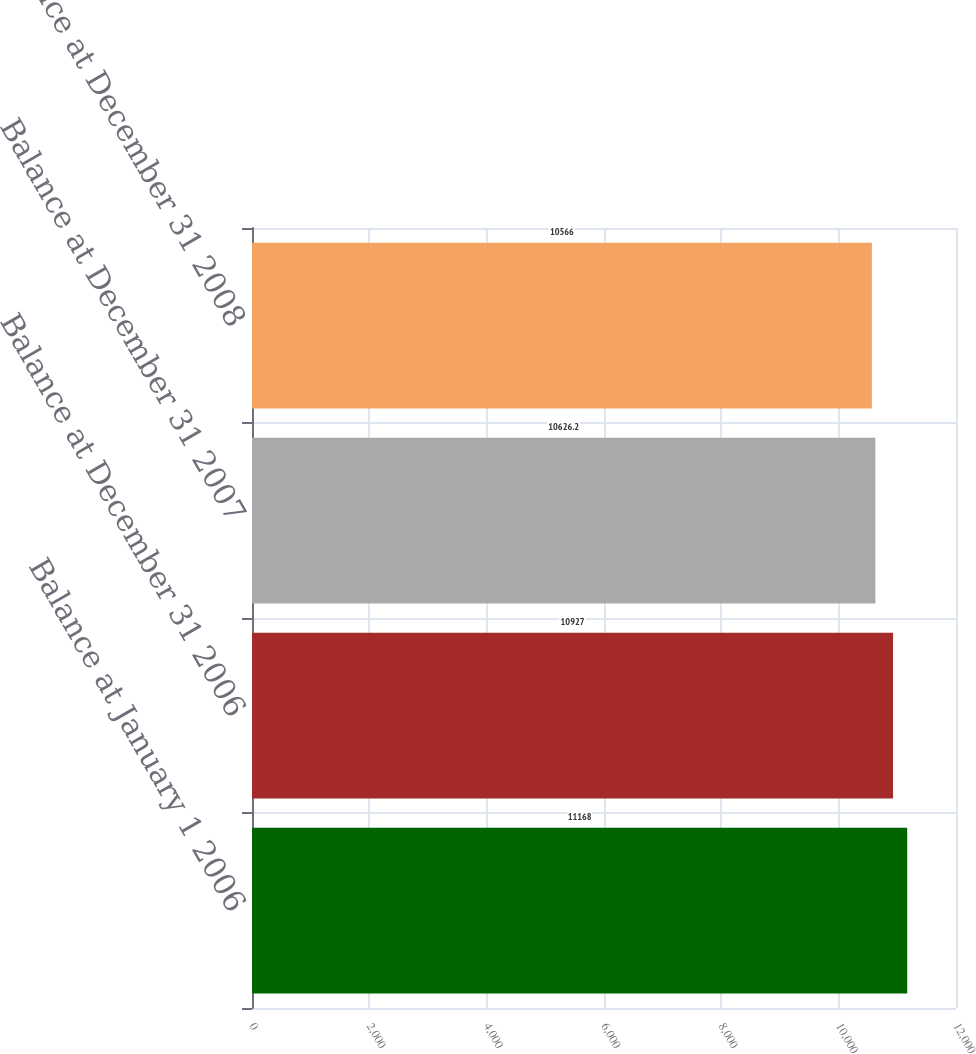<chart> <loc_0><loc_0><loc_500><loc_500><bar_chart><fcel>Balance at January 1 2006<fcel>Balance at December 31 2006<fcel>Balance at December 31 2007<fcel>Balance at December 31 2008<nl><fcel>11168<fcel>10927<fcel>10626.2<fcel>10566<nl></chart> 